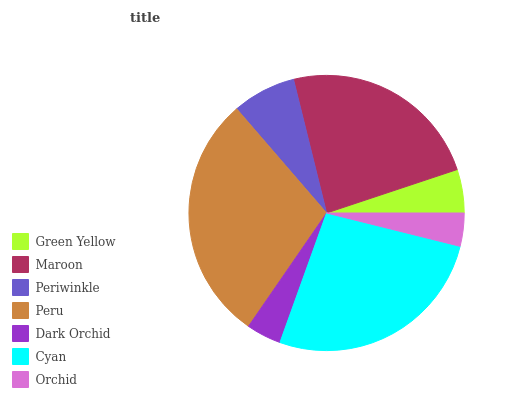Is Orchid the minimum?
Answer yes or no. Yes. Is Peru the maximum?
Answer yes or no. Yes. Is Maroon the minimum?
Answer yes or no. No. Is Maroon the maximum?
Answer yes or no. No. Is Maroon greater than Green Yellow?
Answer yes or no. Yes. Is Green Yellow less than Maroon?
Answer yes or no. Yes. Is Green Yellow greater than Maroon?
Answer yes or no. No. Is Maroon less than Green Yellow?
Answer yes or no. No. Is Periwinkle the high median?
Answer yes or no. Yes. Is Periwinkle the low median?
Answer yes or no. Yes. Is Orchid the high median?
Answer yes or no. No. Is Dark Orchid the low median?
Answer yes or no. No. 